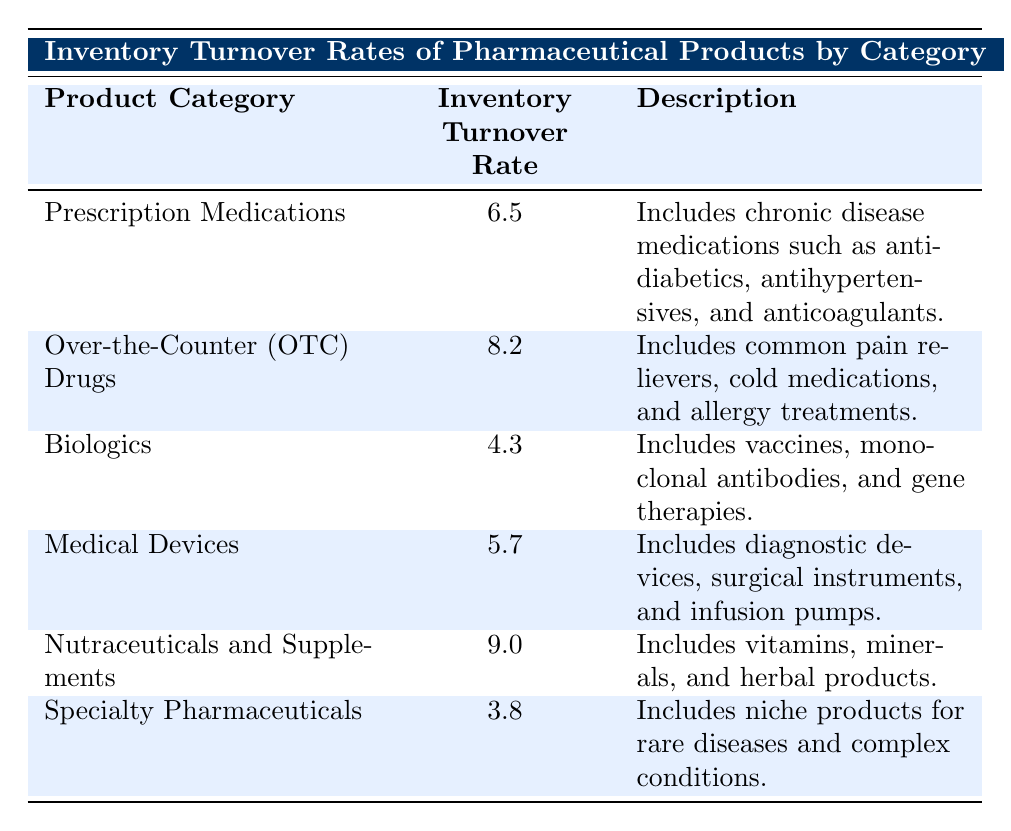What is the inventory turnover rate for Over-the-Counter (OTC) Drugs? The table lists the inventory turnover rates, and for Over-the-Counter (OTC) Drugs, the rate is explicitly stated.
Answer: 8.2 Which product category has the highest inventory turnover rate? By examining the inventory turnover rates listed in the table, Nutraceuticals and Supplements has the highest rate of 9.0 among all the categories.
Answer: Nutraceuticals and Supplements Is the inventory turnover rate for Medical Devices higher than that for Biologics? The rate for Medical Devices is 5.7, while Biologics has a rate of 4.3. Therefore, 5.7 is greater than 4.3.
Answer: Yes What is the average inventory turnover rate of Prescription Medications and Specialty Pharmaceuticals? First, obtain the rates for both categories: Prescription Medications is 6.5 and Specialty Pharmaceuticals is 3.8. The sum is 6.5 + 3.8 = 10.3. Since there are 2 categories, the average is 10.3 / 2 = 5.15.
Answer: 5.15 Which product category has an inventory turnover rate less than 5.0? By reviewing the inventory turnover rates, both Biologics (4.3) and Specialty Pharmaceuticals (3.8) are less than 5.0.
Answer: Biologics and Specialty Pharmaceuticals What is the difference between the turnover rates of Nutraceuticals and Supplements and Specialty Pharmaceuticals? The turnover rate for Nutraceuticals and Supplements is 9.0 and for Specialty Pharmaceuticals, it is 3.8. The difference is calculated as 9.0 - 3.8 = 5.2.
Answer: 5.2 Are there more product categories with an inventory turnover rate greater than 7.0 than below? The product categories with rates above 7.0 are Over-the-Counter (OTC) Drugs (8.2) and Nutraceuticals and Supplements (9.0), making 2 categories. Categories below are Prescription Medications (6.5), Biologics (4.3), Medical Devices (5.7), and Specialty Pharmaceuticals (3.8), making 4 categories. Thus, there are more below.
Answer: No What is the total inventory turnover rate for all product categories combined? To find the total, add all the individual turnover rates: 6.5 + 8.2 + 4.3 + 5.7 + 9.0 + 3.8 = 37.5.
Answer: 37.5 